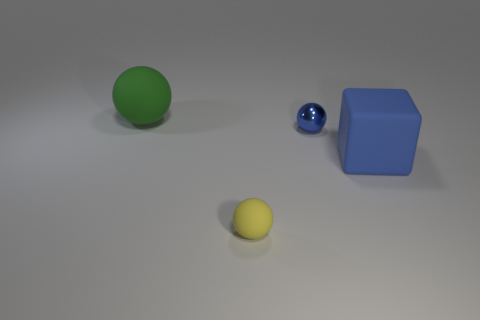What could be the purpose of these objects being together? The arrangement of these objects, with their varying colors, shapes, and sizes, might symbolize diversity or be part of a visual composition demonstrating contrast and comparison. It's also possible they are used in an educational setting to teach about geometry, color theory, or material properties. 